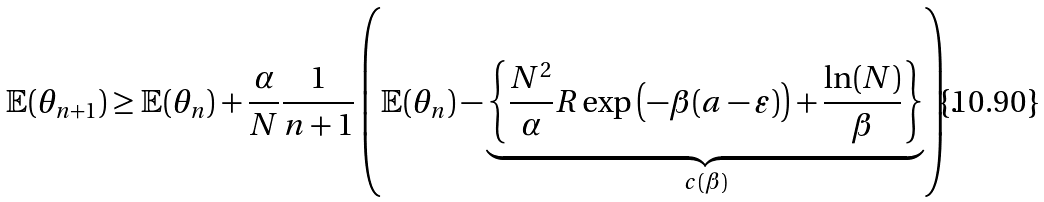<formula> <loc_0><loc_0><loc_500><loc_500>\mathbb { E } ( \theta _ { n + 1 } ) \geq \mathbb { E } ( \theta _ { n } ) + \frac { \alpha } { N } \frac { 1 } { n + 1 } \left ( \mathbb { E } ( \theta _ { n } ) - \underbrace { \left \{ \frac { N ^ { 2 } } { \alpha } R \exp \left ( - \beta ( a - \varepsilon ) \right ) + \frac { \ln ( N ) } { \beta } \right \} } _ { c ( \beta ) } \right ) .</formula> 